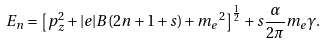<formula> <loc_0><loc_0><loc_500><loc_500>E _ { n } = \left [ p _ { z } ^ { 2 } + | e | B ( 2 n + 1 + s ) + { m _ { e } } ^ { 2 } \right ] ^ { \frac { 1 } { 2 } } + s \frac { \alpha } { 2 \pi } m _ { e } \gamma .</formula> 